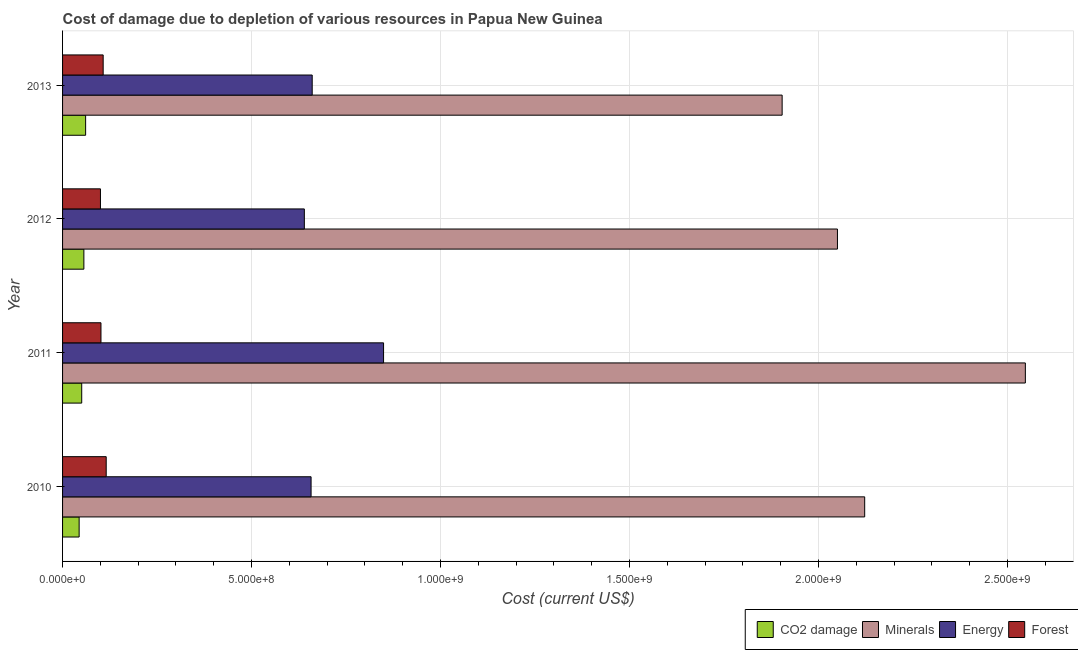Are the number of bars per tick equal to the number of legend labels?
Keep it short and to the point. Yes. Are the number of bars on each tick of the Y-axis equal?
Give a very brief answer. Yes. How many bars are there on the 3rd tick from the bottom?
Offer a very short reply. 4. In how many cases, is the number of bars for a given year not equal to the number of legend labels?
Keep it short and to the point. 0. What is the cost of damage due to depletion of forests in 2013?
Keep it short and to the point. 1.07e+08. Across all years, what is the maximum cost of damage due to depletion of minerals?
Offer a very short reply. 2.55e+09. Across all years, what is the minimum cost of damage due to depletion of energy?
Make the answer very short. 6.40e+08. In which year was the cost of damage due to depletion of coal minimum?
Your answer should be very brief. 2010. What is the total cost of damage due to depletion of energy in the graph?
Your answer should be compact. 2.81e+09. What is the difference between the cost of damage due to depletion of minerals in 2011 and that in 2012?
Your answer should be compact. 4.97e+08. What is the difference between the cost of damage due to depletion of energy in 2013 and the cost of damage due to depletion of coal in 2011?
Give a very brief answer. 6.10e+08. What is the average cost of damage due to depletion of energy per year?
Provide a short and direct response. 7.02e+08. In the year 2011, what is the difference between the cost of damage due to depletion of forests and cost of damage due to depletion of minerals?
Keep it short and to the point. -2.45e+09. In how many years, is the cost of damage due to depletion of energy greater than 1100000000 US$?
Your answer should be compact. 0. What is the ratio of the cost of damage due to depletion of coal in 2011 to that in 2012?
Provide a short and direct response. 0.9. Is the cost of damage due to depletion of forests in 2010 less than that in 2011?
Your answer should be very brief. No. What is the difference between the highest and the second highest cost of damage due to depletion of coal?
Your answer should be compact. 4.64e+06. What is the difference between the highest and the lowest cost of damage due to depletion of forests?
Offer a very short reply. 1.52e+07. What does the 3rd bar from the top in 2011 represents?
Keep it short and to the point. Minerals. What does the 1st bar from the bottom in 2013 represents?
Your answer should be compact. CO2 damage. Are all the bars in the graph horizontal?
Your answer should be very brief. Yes. How many years are there in the graph?
Make the answer very short. 4. What is the difference between two consecutive major ticks on the X-axis?
Ensure brevity in your answer.  5.00e+08. Are the values on the major ticks of X-axis written in scientific E-notation?
Provide a short and direct response. Yes. Does the graph contain any zero values?
Give a very brief answer. No. Where does the legend appear in the graph?
Give a very brief answer. Bottom right. How are the legend labels stacked?
Keep it short and to the point. Horizontal. What is the title of the graph?
Your answer should be very brief. Cost of damage due to depletion of various resources in Papua New Guinea . Does "Corruption" appear as one of the legend labels in the graph?
Make the answer very short. No. What is the label or title of the X-axis?
Give a very brief answer. Cost (current US$). What is the label or title of the Y-axis?
Provide a short and direct response. Year. What is the Cost (current US$) of CO2 damage in 2010?
Keep it short and to the point. 4.38e+07. What is the Cost (current US$) of Minerals in 2010?
Your response must be concise. 2.12e+09. What is the Cost (current US$) in Energy in 2010?
Provide a short and direct response. 6.57e+08. What is the Cost (current US$) of Forest in 2010?
Ensure brevity in your answer.  1.15e+08. What is the Cost (current US$) of CO2 damage in 2011?
Your answer should be compact. 5.07e+07. What is the Cost (current US$) of Minerals in 2011?
Your response must be concise. 2.55e+09. What is the Cost (current US$) in Energy in 2011?
Give a very brief answer. 8.49e+08. What is the Cost (current US$) in Forest in 2011?
Make the answer very short. 1.02e+08. What is the Cost (current US$) of CO2 damage in 2012?
Your answer should be very brief. 5.64e+07. What is the Cost (current US$) in Minerals in 2012?
Keep it short and to the point. 2.05e+09. What is the Cost (current US$) in Energy in 2012?
Provide a short and direct response. 6.40e+08. What is the Cost (current US$) in Forest in 2012?
Make the answer very short. 1.00e+08. What is the Cost (current US$) in CO2 damage in 2013?
Provide a succinct answer. 6.10e+07. What is the Cost (current US$) in Minerals in 2013?
Provide a succinct answer. 1.90e+09. What is the Cost (current US$) of Energy in 2013?
Provide a short and direct response. 6.60e+08. What is the Cost (current US$) in Forest in 2013?
Make the answer very short. 1.07e+08. Across all years, what is the maximum Cost (current US$) of CO2 damage?
Keep it short and to the point. 6.10e+07. Across all years, what is the maximum Cost (current US$) in Minerals?
Offer a very short reply. 2.55e+09. Across all years, what is the maximum Cost (current US$) of Energy?
Offer a very short reply. 8.49e+08. Across all years, what is the maximum Cost (current US$) in Forest?
Make the answer very short. 1.15e+08. Across all years, what is the minimum Cost (current US$) in CO2 damage?
Your answer should be very brief. 4.38e+07. Across all years, what is the minimum Cost (current US$) in Minerals?
Your response must be concise. 1.90e+09. Across all years, what is the minimum Cost (current US$) in Energy?
Keep it short and to the point. 6.40e+08. Across all years, what is the minimum Cost (current US$) of Forest?
Provide a short and direct response. 1.00e+08. What is the total Cost (current US$) of CO2 damage in the graph?
Provide a short and direct response. 2.12e+08. What is the total Cost (current US$) of Minerals in the graph?
Your answer should be very brief. 8.62e+09. What is the total Cost (current US$) of Energy in the graph?
Give a very brief answer. 2.81e+09. What is the total Cost (current US$) in Forest in the graph?
Offer a terse response. 4.25e+08. What is the difference between the Cost (current US$) of CO2 damage in 2010 and that in 2011?
Make the answer very short. -6.85e+06. What is the difference between the Cost (current US$) of Minerals in 2010 and that in 2011?
Give a very brief answer. -4.25e+08. What is the difference between the Cost (current US$) of Energy in 2010 and that in 2011?
Your answer should be compact. -1.92e+08. What is the difference between the Cost (current US$) in Forest in 2010 and that in 2011?
Offer a very short reply. 1.38e+07. What is the difference between the Cost (current US$) of CO2 damage in 2010 and that in 2012?
Provide a short and direct response. -1.25e+07. What is the difference between the Cost (current US$) of Minerals in 2010 and that in 2012?
Your answer should be compact. 7.20e+07. What is the difference between the Cost (current US$) of Energy in 2010 and that in 2012?
Provide a succinct answer. 1.78e+07. What is the difference between the Cost (current US$) of Forest in 2010 and that in 2012?
Make the answer very short. 1.52e+07. What is the difference between the Cost (current US$) of CO2 damage in 2010 and that in 2013?
Offer a very short reply. -1.72e+07. What is the difference between the Cost (current US$) in Minerals in 2010 and that in 2013?
Offer a terse response. 2.18e+08. What is the difference between the Cost (current US$) in Energy in 2010 and that in 2013?
Your answer should be compact. -2.94e+06. What is the difference between the Cost (current US$) of Forest in 2010 and that in 2013?
Your response must be concise. 8.03e+06. What is the difference between the Cost (current US$) in CO2 damage in 2011 and that in 2012?
Ensure brevity in your answer.  -5.67e+06. What is the difference between the Cost (current US$) of Minerals in 2011 and that in 2012?
Provide a succinct answer. 4.97e+08. What is the difference between the Cost (current US$) in Energy in 2011 and that in 2012?
Make the answer very short. 2.10e+08. What is the difference between the Cost (current US$) in Forest in 2011 and that in 2012?
Give a very brief answer. 1.37e+06. What is the difference between the Cost (current US$) in CO2 damage in 2011 and that in 2013?
Offer a very short reply. -1.03e+07. What is the difference between the Cost (current US$) of Minerals in 2011 and that in 2013?
Provide a succinct answer. 6.43e+08. What is the difference between the Cost (current US$) in Energy in 2011 and that in 2013?
Make the answer very short. 1.89e+08. What is the difference between the Cost (current US$) of Forest in 2011 and that in 2013?
Provide a short and direct response. -5.81e+06. What is the difference between the Cost (current US$) of CO2 damage in 2012 and that in 2013?
Your answer should be compact. -4.64e+06. What is the difference between the Cost (current US$) of Minerals in 2012 and that in 2013?
Your answer should be compact. 1.46e+08. What is the difference between the Cost (current US$) of Energy in 2012 and that in 2013?
Your answer should be compact. -2.08e+07. What is the difference between the Cost (current US$) in Forest in 2012 and that in 2013?
Provide a short and direct response. -7.18e+06. What is the difference between the Cost (current US$) in CO2 damage in 2010 and the Cost (current US$) in Minerals in 2011?
Provide a succinct answer. -2.50e+09. What is the difference between the Cost (current US$) of CO2 damage in 2010 and the Cost (current US$) of Energy in 2011?
Offer a terse response. -8.05e+08. What is the difference between the Cost (current US$) in CO2 damage in 2010 and the Cost (current US$) in Forest in 2011?
Give a very brief answer. -5.78e+07. What is the difference between the Cost (current US$) of Minerals in 2010 and the Cost (current US$) of Energy in 2011?
Make the answer very short. 1.27e+09. What is the difference between the Cost (current US$) in Minerals in 2010 and the Cost (current US$) in Forest in 2011?
Ensure brevity in your answer.  2.02e+09. What is the difference between the Cost (current US$) in Energy in 2010 and the Cost (current US$) in Forest in 2011?
Keep it short and to the point. 5.56e+08. What is the difference between the Cost (current US$) in CO2 damage in 2010 and the Cost (current US$) in Minerals in 2012?
Ensure brevity in your answer.  -2.01e+09. What is the difference between the Cost (current US$) in CO2 damage in 2010 and the Cost (current US$) in Energy in 2012?
Give a very brief answer. -5.96e+08. What is the difference between the Cost (current US$) in CO2 damage in 2010 and the Cost (current US$) in Forest in 2012?
Offer a terse response. -5.64e+07. What is the difference between the Cost (current US$) of Minerals in 2010 and the Cost (current US$) of Energy in 2012?
Your answer should be compact. 1.48e+09. What is the difference between the Cost (current US$) of Minerals in 2010 and the Cost (current US$) of Forest in 2012?
Give a very brief answer. 2.02e+09. What is the difference between the Cost (current US$) of Energy in 2010 and the Cost (current US$) of Forest in 2012?
Your answer should be compact. 5.57e+08. What is the difference between the Cost (current US$) of CO2 damage in 2010 and the Cost (current US$) of Minerals in 2013?
Offer a very short reply. -1.86e+09. What is the difference between the Cost (current US$) of CO2 damage in 2010 and the Cost (current US$) of Energy in 2013?
Give a very brief answer. -6.17e+08. What is the difference between the Cost (current US$) in CO2 damage in 2010 and the Cost (current US$) in Forest in 2013?
Offer a very short reply. -6.36e+07. What is the difference between the Cost (current US$) of Minerals in 2010 and the Cost (current US$) of Energy in 2013?
Offer a terse response. 1.46e+09. What is the difference between the Cost (current US$) in Minerals in 2010 and the Cost (current US$) in Forest in 2013?
Your answer should be very brief. 2.01e+09. What is the difference between the Cost (current US$) in Energy in 2010 and the Cost (current US$) in Forest in 2013?
Provide a short and direct response. 5.50e+08. What is the difference between the Cost (current US$) of CO2 damage in 2011 and the Cost (current US$) of Minerals in 2012?
Give a very brief answer. -2.00e+09. What is the difference between the Cost (current US$) in CO2 damage in 2011 and the Cost (current US$) in Energy in 2012?
Your response must be concise. -5.89e+08. What is the difference between the Cost (current US$) in CO2 damage in 2011 and the Cost (current US$) in Forest in 2012?
Offer a terse response. -4.95e+07. What is the difference between the Cost (current US$) of Minerals in 2011 and the Cost (current US$) of Energy in 2012?
Provide a short and direct response. 1.91e+09. What is the difference between the Cost (current US$) in Minerals in 2011 and the Cost (current US$) in Forest in 2012?
Give a very brief answer. 2.45e+09. What is the difference between the Cost (current US$) of Energy in 2011 and the Cost (current US$) of Forest in 2012?
Your answer should be very brief. 7.49e+08. What is the difference between the Cost (current US$) of CO2 damage in 2011 and the Cost (current US$) of Minerals in 2013?
Offer a very short reply. -1.85e+09. What is the difference between the Cost (current US$) of CO2 damage in 2011 and the Cost (current US$) of Energy in 2013?
Ensure brevity in your answer.  -6.10e+08. What is the difference between the Cost (current US$) of CO2 damage in 2011 and the Cost (current US$) of Forest in 2013?
Your answer should be very brief. -5.67e+07. What is the difference between the Cost (current US$) of Minerals in 2011 and the Cost (current US$) of Energy in 2013?
Your answer should be very brief. 1.89e+09. What is the difference between the Cost (current US$) of Minerals in 2011 and the Cost (current US$) of Forest in 2013?
Ensure brevity in your answer.  2.44e+09. What is the difference between the Cost (current US$) of Energy in 2011 and the Cost (current US$) of Forest in 2013?
Your response must be concise. 7.42e+08. What is the difference between the Cost (current US$) of CO2 damage in 2012 and the Cost (current US$) of Minerals in 2013?
Your answer should be very brief. -1.85e+09. What is the difference between the Cost (current US$) in CO2 damage in 2012 and the Cost (current US$) in Energy in 2013?
Give a very brief answer. -6.04e+08. What is the difference between the Cost (current US$) in CO2 damage in 2012 and the Cost (current US$) in Forest in 2013?
Your response must be concise. -5.11e+07. What is the difference between the Cost (current US$) in Minerals in 2012 and the Cost (current US$) in Energy in 2013?
Offer a terse response. 1.39e+09. What is the difference between the Cost (current US$) of Minerals in 2012 and the Cost (current US$) of Forest in 2013?
Give a very brief answer. 1.94e+09. What is the difference between the Cost (current US$) of Energy in 2012 and the Cost (current US$) of Forest in 2013?
Keep it short and to the point. 5.32e+08. What is the average Cost (current US$) in CO2 damage per year?
Offer a very short reply. 5.30e+07. What is the average Cost (current US$) in Minerals per year?
Offer a terse response. 2.16e+09. What is the average Cost (current US$) of Energy per year?
Your response must be concise. 7.02e+08. What is the average Cost (current US$) in Forest per year?
Provide a short and direct response. 1.06e+08. In the year 2010, what is the difference between the Cost (current US$) in CO2 damage and Cost (current US$) in Minerals?
Ensure brevity in your answer.  -2.08e+09. In the year 2010, what is the difference between the Cost (current US$) of CO2 damage and Cost (current US$) of Energy?
Ensure brevity in your answer.  -6.14e+08. In the year 2010, what is the difference between the Cost (current US$) of CO2 damage and Cost (current US$) of Forest?
Offer a terse response. -7.16e+07. In the year 2010, what is the difference between the Cost (current US$) of Minerals and Cost (current US$) of Energy?
Offer a very short reply. 1.46e+09. In the year 2010, what is the difference between the Cost (current US$) in Minerals and Cost (current US$) in Forest?
Your answer should be very brief. 2.01e+09. In the year 2010, what is the difference between the Cost (current US$) in Energy and Cost (current US$) in Forest?
Your response must be concise. 5.42e+08. In the year 2011, what is the difference between the Cost (current US$) of CO2 damage and Cost (current US$) of Minerals?
Your response must be concise. -2.50e+09. In the year 2011, what is the difference between the Cost (current US$) in CO2 damage and Cost (current US$) in Energy?
Your answer should be very brief. -7.98e+08. In the year 2011, what is the difference between the Cost (current US$) of CO2 damage and Cost (current US$) of Forest?
Your response must be concise. -5.09e+07. In the year 2011, what is the difference between the Cost (current US$) in Minerals and Cost (current US$) in Energy?
Provide a succinct answer. 1.70e+09. In the year 2011, what is the difference between the Cost (current US$) of Minerals and Cost (current US$) of Forest?
Provide a succinct answer. 2.45e+09. In the year 2011, what is the difference between the Cost (current US$) of Energy and Cost (current US$) of Forest?
Make the answer very short. 7.48e+08. In the year 2012, what is the difference between the Cost (current US$) of CO2 damage and Cost (current US$) of Minerals?
Keep it short and to the point. -1.99e+09. In the year 2012, what is the difference between the Cost (current US$) in CO2 damage and Cost (current US$) in Energy?
Provide a succinct answer. -5.83e+08. In the year 2012, what is the difference between the Cost (current US$) of CO2 damage and Cost (current US$) of Forest?
Give a very brief answer. -4.39e+07. In the year 2012, what is the difference between the Cost (current US$) of Minerals and Cost (current US$) of Energy?
Give a very brief answer. 1.41e+09. In the year 2012, what is the difference between the Cost (current US$) in Minerals and Cost (current US$) in Forest?
Keep it short and to the point. 1.95e+09. In the year 2012, what is the difference between the Cost (current US$) in Energy and Cost (current US$) in Forest?
Keep it short and to the point. 5.39e+08. In the year 2013, what is the difference between the Cost (current US$) of CO2 damage and Cost (current US$) of Minerals?
Give a very brief answer. -1.84e+09. In the year 2013, what is the difference between the Cost (current US$) in CO2 damage and Cost (current US$) in Energy?
Make the answer very short. -5.99e+08. In the year 2013, what is the difference between the Cost (current US$) of CO2 damage and Cost (current US$) of Forest?
Make the answer very short. -4.64e+07. In the year 2013, what is the difference between the Cost (current US$) in Minerals and Cost (current US$) in Energy?
Provide a short and direct response. 1.24e+09. In the year 2013, what is the difference between the Cost (current US$) of Minerals and Cost (current US$) of Forest?
Provide a succinct answer. 1.80e+09. In the year 2013, what is the difference between the Cost (current US$) in Energy and Cost (current US$) in Forest?
Provide a succinct answer. 5.53e+08. What is the ratio of the Cost (current US$) of CO2 damage in 2010 to that in 2011?
Provide a succinct answer. 0.86. What is the ratio of the Cost (current US$) in Minerals in 2010 to that in 2011?
Offer a very short reply. 0.83. What is the ratio of the Cost (current US$) in Energy in 2010 to that in 2011?
Offer a very short reply. 0.77. What is the ratio of the Cost (current US$) in Forest in 2010 to that in 2011?
Your answer should be compact. 1.14. What is the ratio of the Cost (current US$) of CO2 damage in 2010 to that in 2012?
Your answer should be very brief. 0.78. What is the ratio of the Cost (current US$) in Minerals in 2010 to that in 2012?
Provide a succinct answer. 1.04. What is the ratio of the Cost (current US$) in Energy in 2010 to that in 2012?
Provide a short and direct response. 1.03. What is the ratio of the Cost (current US$) of Forest in 2010 to that in 2012?
Keep it short and to the point. 1.15. What is the ratio of the Cost (current US$) of CO2 damage in 2010 to that in 2013?
Ensure brevity in your answer.  0.72. What is the ratio of the Cost (current US$) in Minerals in 2010 to that in 2013?
Offer a terse response. 1.11. What is the ratio of the Cost (current US$) in Energy in 2010 to that in 2013?
Your answer should be very brief. 1. What is the ratio of the Cost (current US$) of Forest in 2010 to that in 2013?
Your answer should be very brief. 1.07. What is the ratio of the Cost (current US$) in CO2 damage in 2011 to that in 2012?
Make the answer very short. 0.9. What is the ratio of the Cost (current US$) in Minerals in 2011 to that in 2012?
Offer a very short reply. 1.24. What is the ratio of the Cost (current US$) in Energy in 2011 to that in 2012?
Offer a terse response. 1.33. What is the ratio of the Cost (current US$) in Forest in 2011 to that in 2012?
Ensure brevity in your answer.  1.01. What is the ratio of the Cost (current US$) of CO2 damage in 2011 to that in 2013?
Your answer should be very brief. 0.83. What is the ratio of the Cost (current US$) in Minerals in 2011 to that in 2013?
Give a very brief answer. 1.34. What is the ratio of the Cost (current US$) of Energy in 2011 to that in 2013?
Your answer should be very brief. 1.29. What is the ratio of the Cost (current US$) of Forest in 2011 to that in 2013?
Make the answer very short. 0.95. What is the ratio of the Cost (current US$) of CO2 damage in 2012 to that in 2013?
Your response must be concise. 0.92. What is the ratio of the Cost (current US$) in Energy in 2012 to that in 2013?
Give a very brief answer. 0.97. What is the ratio of the Cost (current US$) of Forest in 2012 to that in 2013?
Your answer should be very brief. 0.93. What is the difference between the highest and the second highest Cost (current US$) in CO2 damage?
Give a very brief answer. 4.64e+06. What is the difference between the highest and the second highest Cost (current US$) in Minerals?
Offer a very short reply. 4.25e+08. What is the difference between the highest and the second highest Cost (current US$) in Energy?
Ensure brevity in your answer.  1.89e+08. What is the difference between the highest and the second highest Cost (current US$) of Forest?
Keep it short and to the point. 8.03e+06. What is the difference between the highest and the lowest Cost (current US$) in CO2 damage?
Provide a succinct answer. 1.72e+07. What is the difference between the highest and the lowest Cost (current US$) of Minerals?
Your answer should be compact. 6.43e+08. What is the difference between the highest and the lowest Cost (current US$) of Energy?
Your response must be concise. 2.10e+08. What is the difference between the highest and the lowest Cost (current US$) of Forest?
Provide a short and direct response. 1.52e+07. 